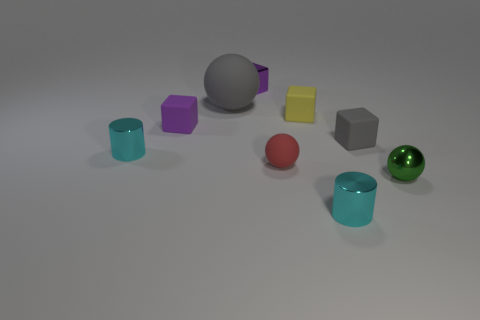There is a large gray thing behind the shiny thing on the right side of the metallic cylinder that is right of the small yellow matte cube; what shape is it?
Ensure brevity in your answer.  Sphere. The metal object that is both in front of the big matte object and behind the tiny red matte sphere is what color?
Offer a very short reply. Cyan. What is the shape of the gray rubber thing that is to the right of the red matte thing?
Keep it short and to the point. Cube. There is a large thing that is the same material as the tiny gray thing; what is its shape?
Offer a terse response. Sphere. What number of rubber objects are either tiny cubes or green spheres?
Provide a short and direct response. 3. There is a small metallic object on the right side of the tiny block that is right of the yellow object; what number of small cyan objects are right of it?
Ensure brevity in your answer.  0. There is a ball behind the tiny red rubber object; does it have the same size as the sphere to the right of the tiny gray rubber cube?
Your answer should be compact. No. There is a gray thing that is the same shape as the yellow matte thing; what material is it?
Your response must be concise. Rubber. How many big things are either green shiny things or yellow matte balls?
Your response must be concise. 0. What is the yellow thing made of?
Ensure brevity in your answer.  Rubber. 